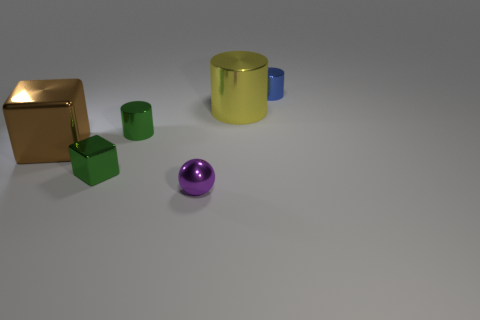Subtract all tiny shiny cylinders. How many cylinders are left? 1 Add 3 metallic things. How many objects exist? 9 Subtract all purple cylinders. Subtract all brown blocks. How many cylinders are left? 3 Subtract all blocks. How many objects are left? 4 Subtract all large brown things. Subtract all tiny green cylinders. How many objects are left? 4 Add 5 large brown shiny blocks. How many large brown shiny blocks are left? 6 Add 2 small gray blocks. How many small gray blocks exist? 2 Subtract 0 cyan cubes. How many objects are left? 6 